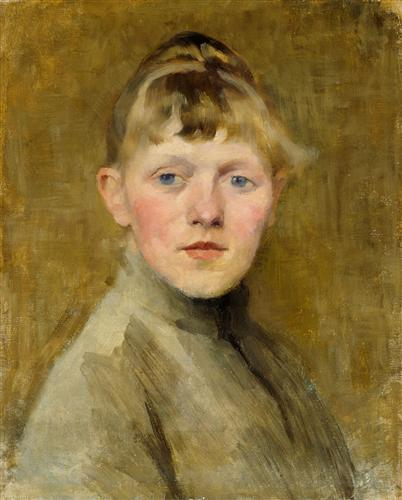Analyze the image in a comprehensive and detailed manner. The image features a portrait of a young boy, depicted with striking realism tinged with impressionistic techniques. His soft, blonde hair and clear blue eyes convey innocence and a gentle demeanor, set against a soft, golden-hued background that complements his youthful purity. The artist employs a loose yet deliberate brushwork typical of impressionism, which adds a dynamic and somewhat introspective quality to the painting. The boy's attire, a simple grey jacket with a stark white collar, subtly hints at the era of the painting, likely late 19th century. This portrait not only captures the boy's physical characteristics but also seems to subtly explore themes of youth and perhaps the social context of the subject, inviting viewers to ponder the life and times of the boy depicted. 